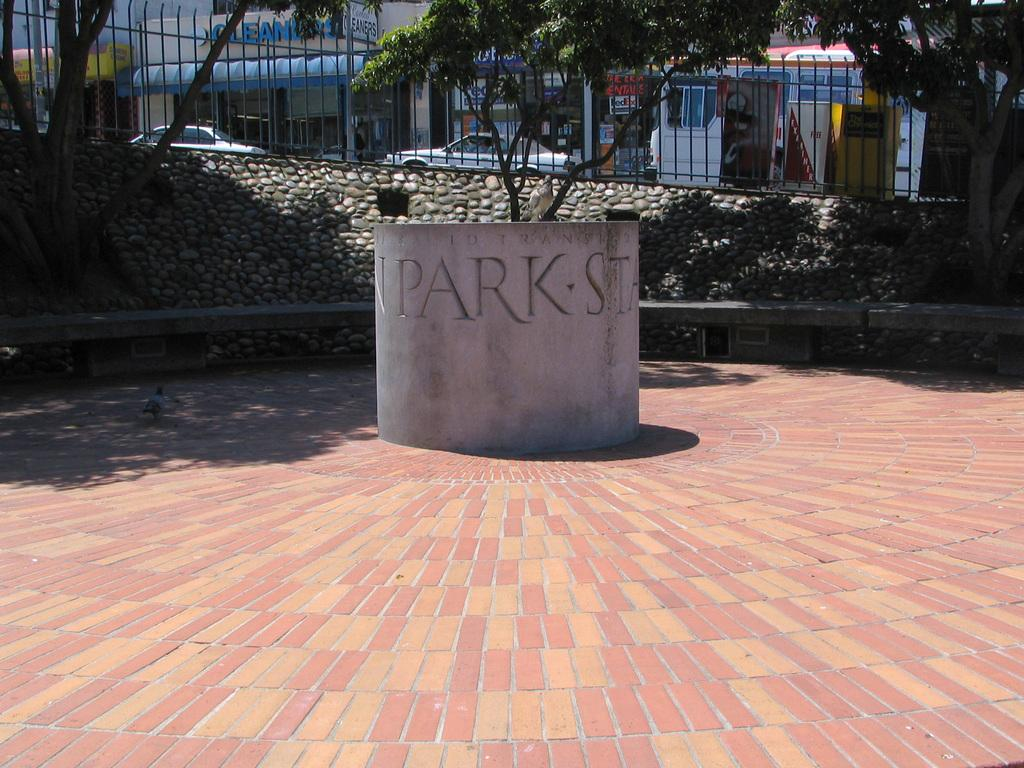What is the main object in the image? There is a rock in the image. What can be seen in the background of the image? There are many trees in the background. What is located near the rock? There is railing in the image. What can be seen to the side of the railing? Cars and boards are visible to the side of the railing. What type of structures are visible in the image? There are buildings visible in the image. What type of badge is being worn by the rock in the image? There is no badge present in the image, as the main subject is a rock. Can you tell me how many socks are visible on the rock in the image? There are no socks visible in the image, as the main subject is a rock. 